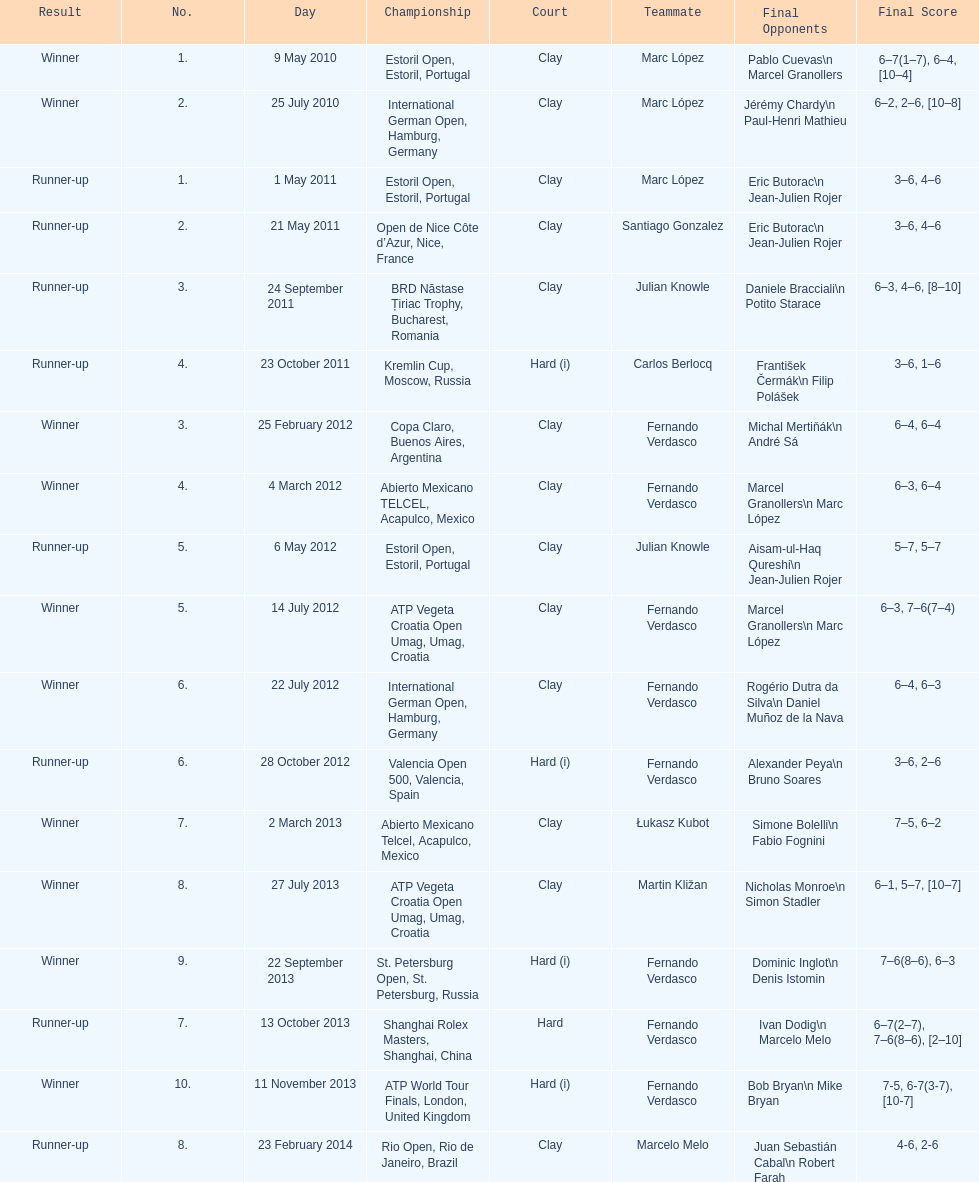What tournament was played after the kremlin cup? Copa Claro, Buenos Aires, Argentina. 